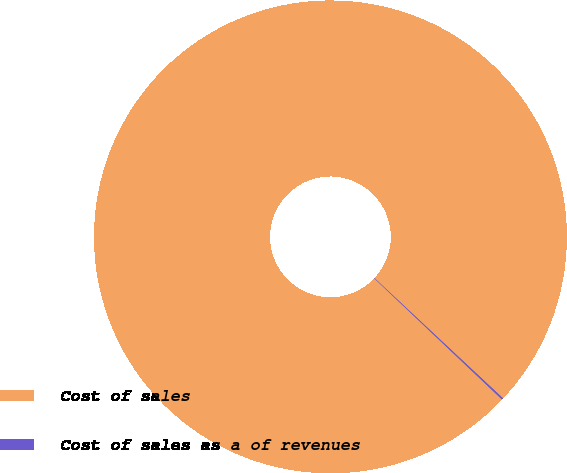Convert chart. <chart><loc_0><loc_0><loc_500><loc_500><pie_chart><fcel>Cost of sales<fcel>Cost of sales as a of revenues<nl><fcel>99.89%<fcel>0.11%<nl></chart> 